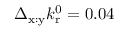<formula> <loc_0><loc_0><loc_500><loc_500>\Delta _ { x \colon y } k _ { r } ^ { 0 } = 0 . 0 4</formula> 